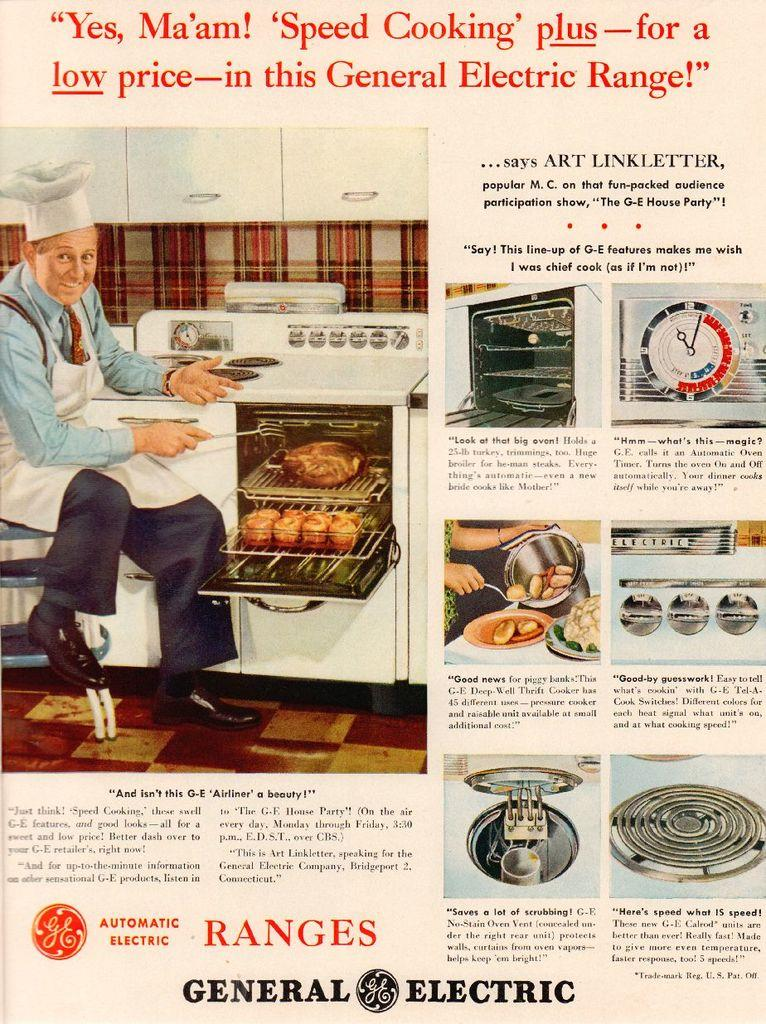<image>
Create a compact narrative representing the image presented. an ad for an old GE electric range has a man cooking several items 